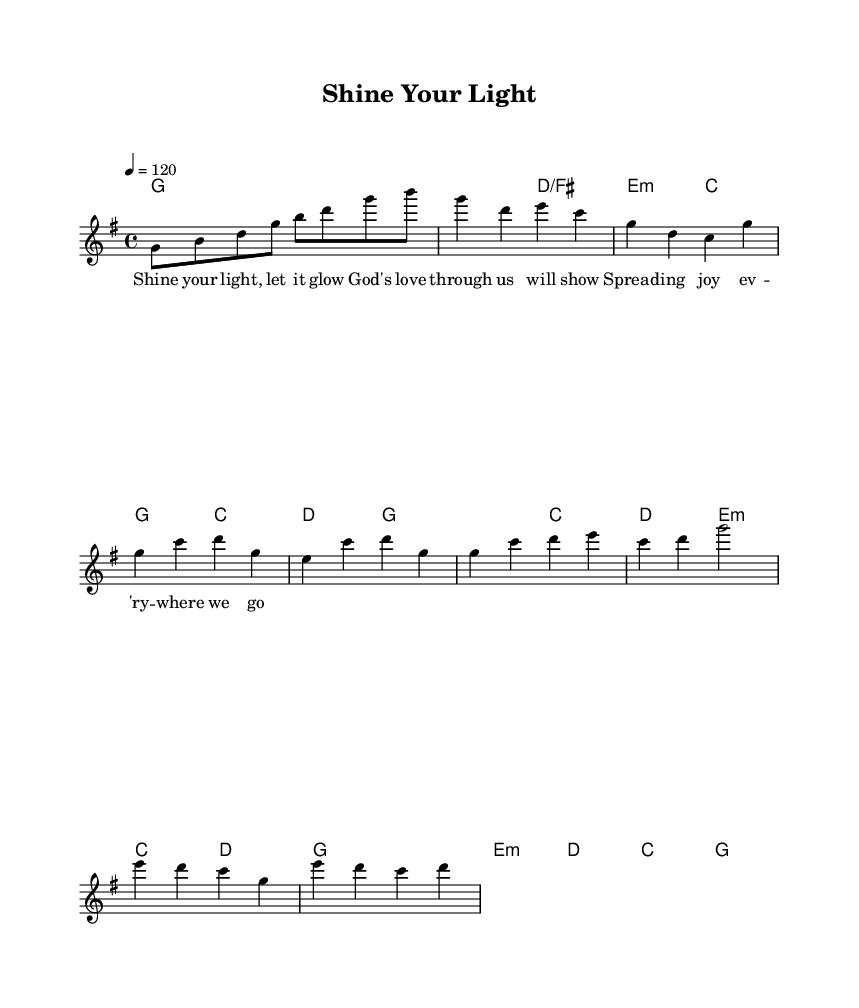What is the key signature of this music? The key signature is G major, which contains one sharp (F#). This can be identified at the beginning of the score where the key signature is indicated.
Answer: G major What is the time signature of this music? The time signature is 4/4, which can be seen at the beginning of the score. This means there are four beats in each measure and the quarter note gets one beat.
Answer: 4/4 What is the tempo marking for this piece? The tempo marking is 120 beats per minute (quarter note equals 120), indicated in the tempo section of the score. This directs how fast the music should be played.
Answer: 120 How many measures are in the chorus section? The chorus section contains 6 measures, which can be counted by identifying the measures in the musical notation corresponding to the chorus lyrics.
Answer: 6 What chord follows the A minor chord in the chorus? The chord that follows the A minor chord is C major. This can be deduced by looking at the chord names listed above the notes in the chorus, specifically right after the E minor chord.
Answer: C What is the main theme of the lyrics associated with this piece? The main theme of the lyrics is about shining light and spreading joy, reflected in the text provided which emphasizes God’s love and positivity.
Answer: Shine your light What musical genre does this piece belong to? This piece belongs to the disco genre, which is characterized by its danceable rhythm and soulful vocal style, evident in its upbeat vibe and structure.
Answer: Disco 